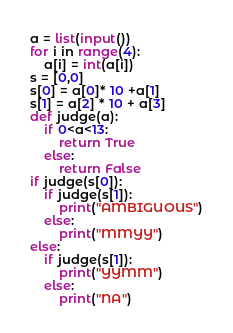<code> <loc_0><loc_0><loc_500><loc_500><_Python_>a = list(input())
for i in range(4):
	a[i] = int(a[i])
s = [0,0]
s[0] = a[0]* 10 +a[1]
s[1] = a[2] * 10 + a[3]
def judge(a):
	if 0<a<13:
		return True
	else:
		return False
if judge(s[0]):
	if judge(s[1]):
		print("AMBIGUOUS")
	else:
		print("MMYY")
else:
	if judge(s[1]):
		print("YYMM")
	else:
		print("NA")

</code> 